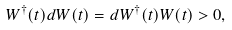<formula> <loc_0><loc_0><loc_500><loc_500>W ^ { \dagger } ( t ) d W ( t ) = d W ^ { \dagger } ( t ) W ( t ) > 0 ,</formula> 